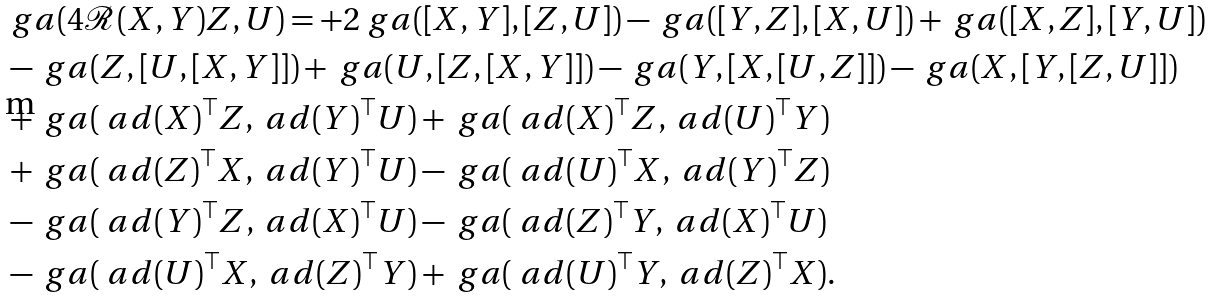Convert formula to latex. <formula><loc_0><loc_0><loc_500><loc_500>& \ g a ( 4 \mathcal { R } ( X , Y ) Z , U ) = + 2 \ g a ( [ X , Y ] , [ Z , U ] ) - \ g a ( [ Y , Z ] , [ X , U ] ) + \ g a ( [ X , Z ] , [ Y , U ] ) \\ & - \ g a ( Z , [ U , [ X , Y ] ] ) + \ g a ( U , [ Z , [ X , Y ] ] ) - \ g a ( Y , [ X , [ U , Z ] ] ) - \ g a ( X , [ Y , [ Z , U ] ] ) \\ & + \ g a ( \ a d ( X ) ^ { \top } Z , \ a d ( Y ) ^ { \top } U ) + \ g a ( \ a d ( X ) ^ { \top } Z , \ a d ( U ) ^ { \top } Y ) \\ & + \ g a ( \ a d ( Z ) ^ { \top } X , \ a d ( Y ) ^ { \top } U ) - \ g a ( \ a d ( U ) ^ { \top } X , \ a d ( Y ) ^ { \top } Z ) \\ & - \ g a ( \ a d ( Y ) ^ { \top } Z , \ a d ( X ) ^ { \top } U ) - \ g a ( \ a d ( Z ) ^ { \top } Y , \ a d ( X ) ^ { \top } U ) \\ & - \ g a ( \ a d ( U ) ^ { \top } X , \ a d ( Z ) ^ { \top } Y ) + \ g a ( \ a d ( U ) ^ { \top } Y , \ a d ( Z ) ^ { \top } X ) .</formula> 